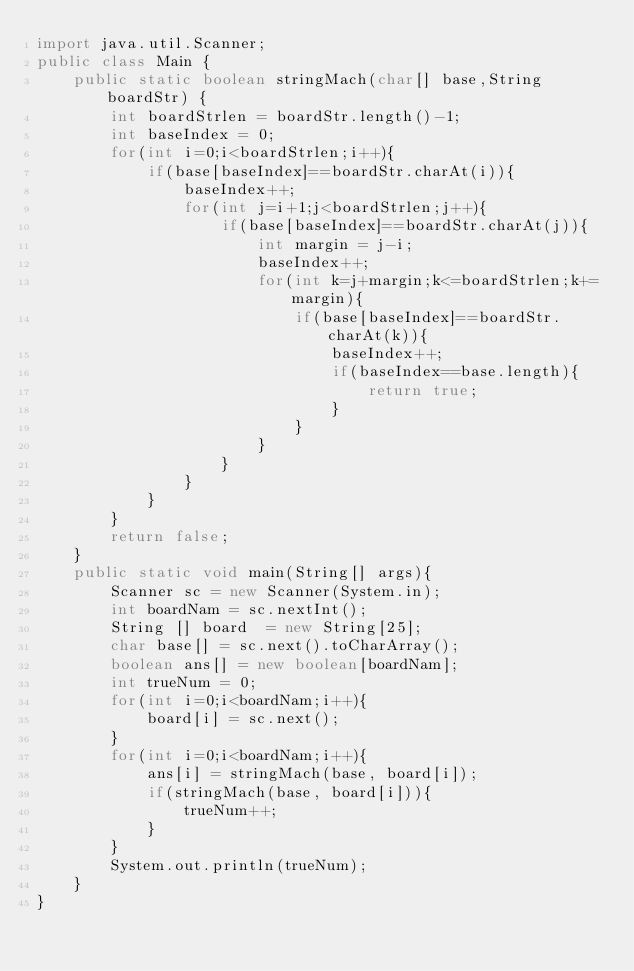Convert code to text. <code><loc_0><loc_0><loc_500><loc_500><_Java_>import java.util.Scanner;
public class Main {
	public static boolean stringMach(char[] base,String boardStr) {
		int boardStrlen = boardStr.length()-1; 
		int baseIndex = 0;
		for(int i=0;i<boardStrlen;i++){
			if(base[baseIndex]==boardStr.charAt(i)){
				baseIndex++;
				for(int j=i+1;j<boardStrlen;j++){
					if(base[baseIndex]==boardStr.charAt(j)){
						int margin = j-i;
						baseIndex++;
						for(int k=j+margin;k<=boardStrlen;k+=margin){
							if(base[baseIndex]==boardStr.charAt(k)){
								baseIndex++;
								if(baseIndex==base.length){
									return true;
								}
							}
						}
					}
				}
			}
		}
		return false;
	}
	public static void main(String[] args){
		Scanner sc = new Scanner(System.in);
		int boardNam = sc.nextInt();
		String [] board  = new String[25];
		char base[] = sc.next().toCharArray();
		boolean ans[] = new boolean[boardNam];
		int trueNum = 0;
		for(int i=0;i<boardNam;i++){
			board[i] = sc.next();
		}
		for(int i=0;i<boardNam;i++){
			ans[i] = stringMach(base, board[i]);
			if(stringMach(base, board[i])){
				trueNum++;
			}
		}
		System.out.println(trueNum);
	}
}</code> 